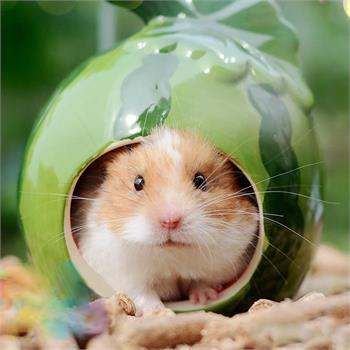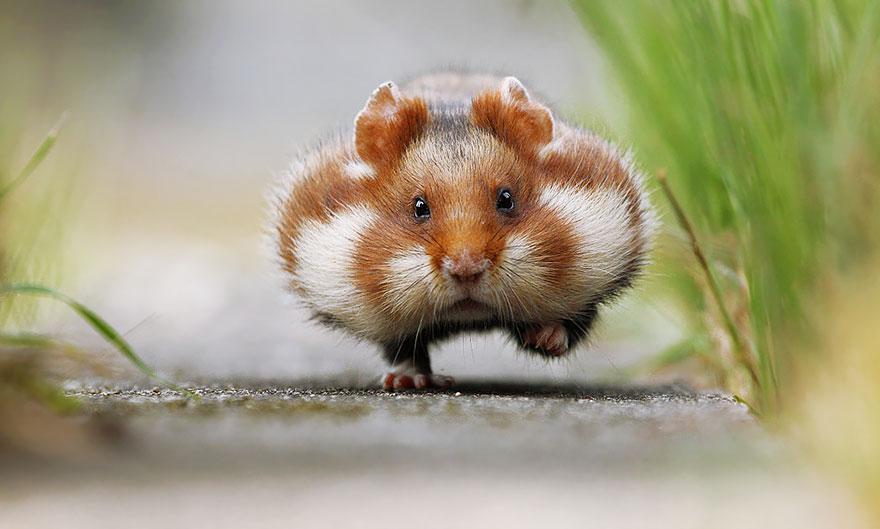The first image is the image on the left, the second image is the image on the right. For the images shown, is this caption "One of the animals is sitting on a rock." true? Answer yes or no. No. 